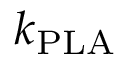<formula> <loc_0><loc_0><loc_500><loc_500>k _ { P L A }</formula> 